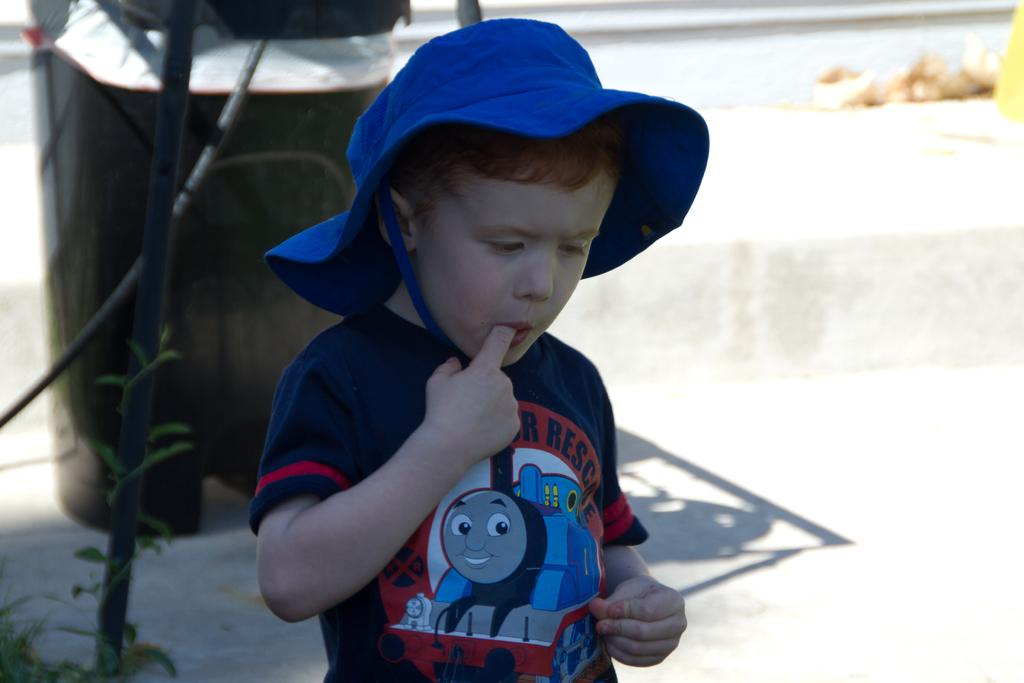Who is the main subject in the image? There is a boy in the image. What is the boy wearing on his head? The boy is wearing a hat. What objects can be seen in the background of the image? There is a rod, a dustbin, and a plant in the background of the image. How would you describe the background of the image? The background is blurred. How many boys are flying a plane in the image? There are no boys flying a plane in the image; it only features a boy wearing a hat. What type of roof is visible in the image? There is no roof present in the image. 